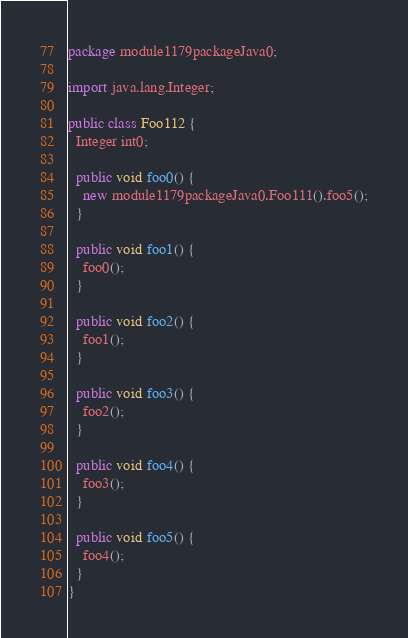<code> <loc_0><loc_0><loc_500><loc_500><_Java_>package module1179packageJava0;

import java.lang.Integer;

public class Foo112 {
  Integer int0;

  public void foo0() {
    new module1179packageJava0.Foo111().foo5();
  }

  public void foo1() {
    foo0();
  }

  public void foo2() {
    foo1();
  }

  public void foo3() {
    foo2();
  }

  public void foo4() {
    foo3();
  }

  public void foo5() {
    foo4();
  }
}
</code> 